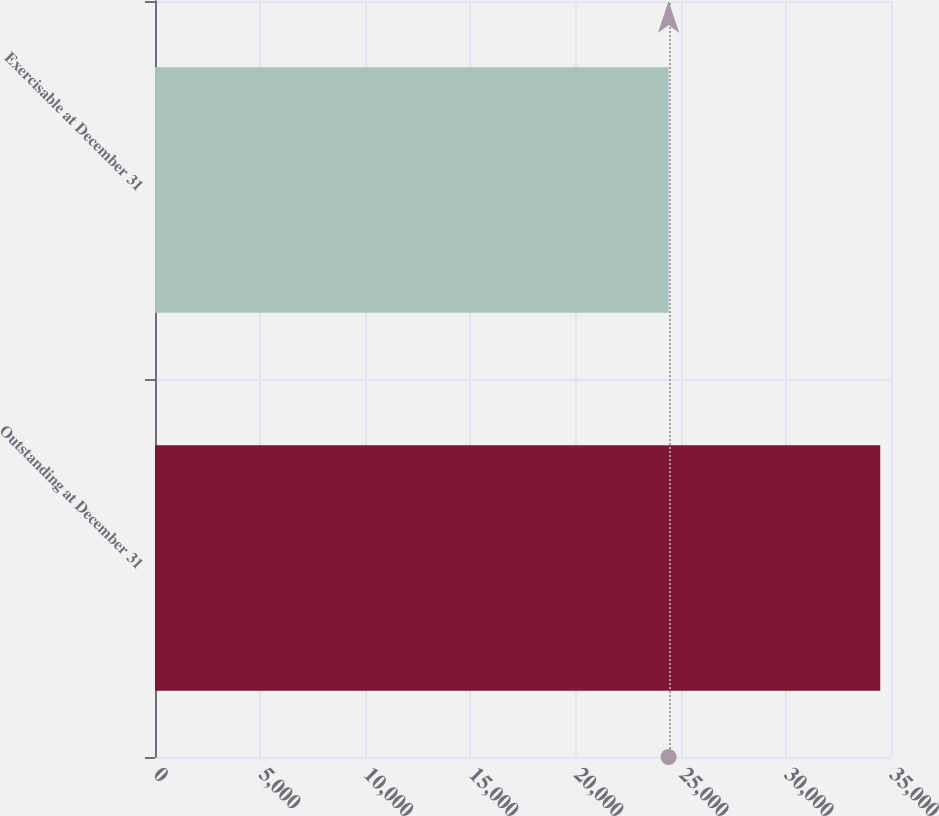Convert chart to OTSL. <chart><loc_0><loc_0><loc_500><loc_500><bar_chart><fcel>Outstanding at December 31<fcel>Exercisable at December 31<nl><fcel>34487<fcel>24424<nl></chart> 